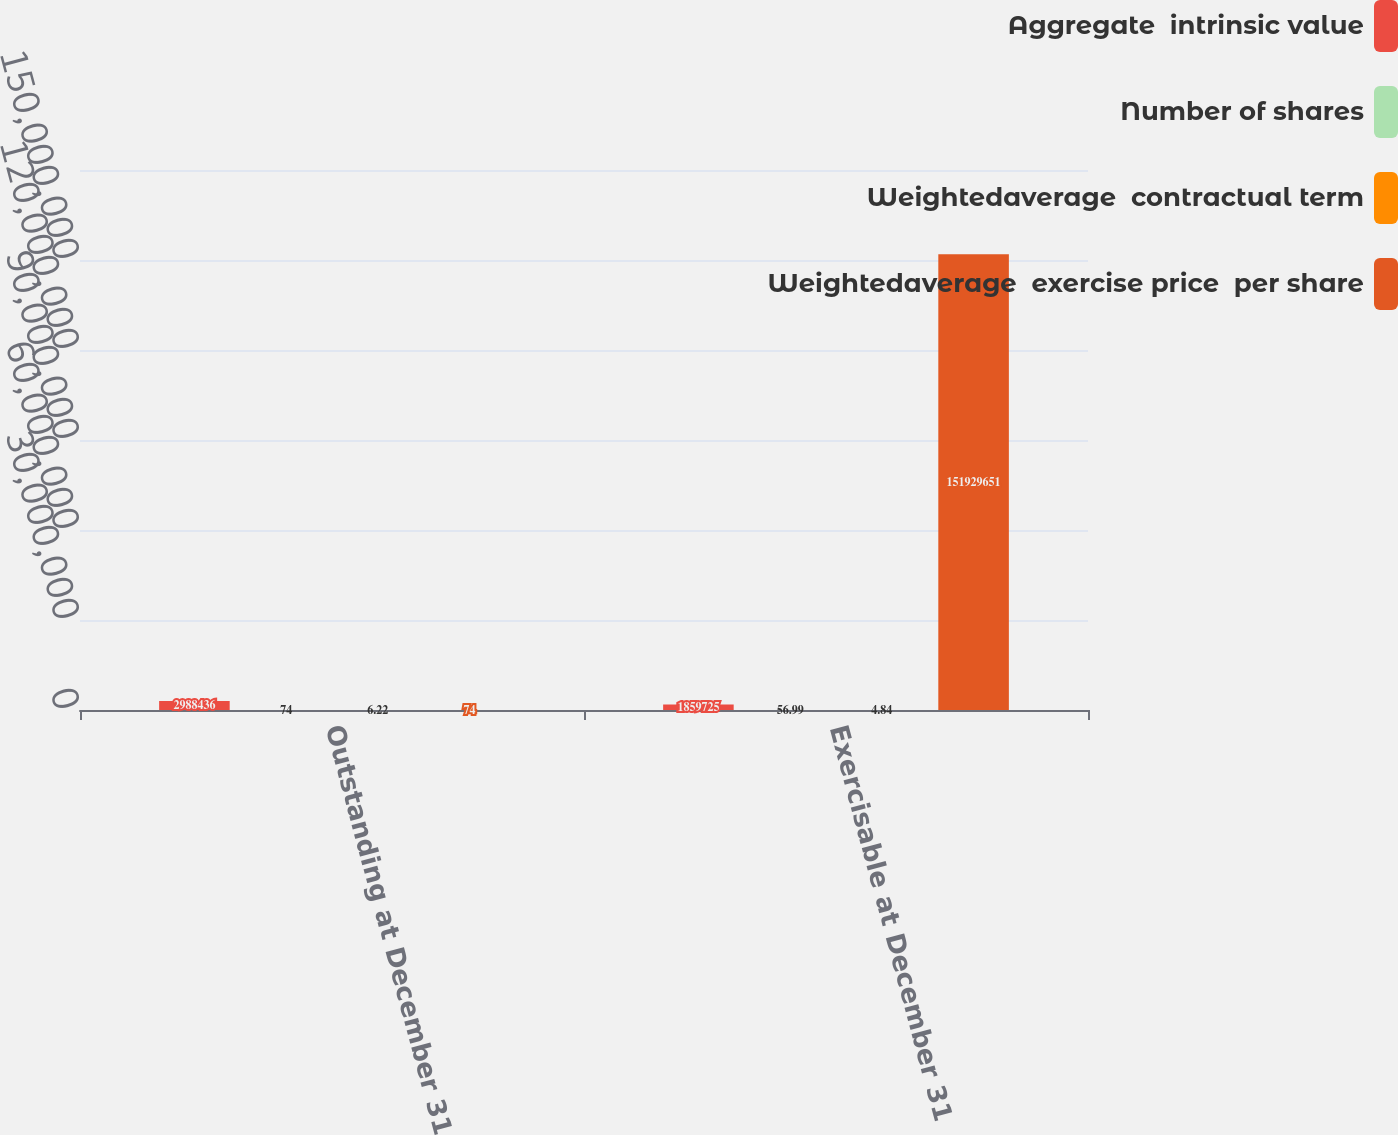<chart> <loc_0><loc_0><loc_500><loc_500><stacked_bar_chart><ecel><fcel>Outstanding at December 31<fcel>Exercisable at December 31<nl><fcel>Aggregate  intrinsic value<fcel>2.98844e+06<fcel>1.85972e+06<nl><fcel>Number of shares<fcel>74<fcel>56.99<nl><fcel>Weightedaverage  contractual term<fcel>6.22<fcel>4.84<nl><fcel>Weightedaverage  exercise price  per share<fcel>74<fcel>1.5193e+08<nl></chart> 